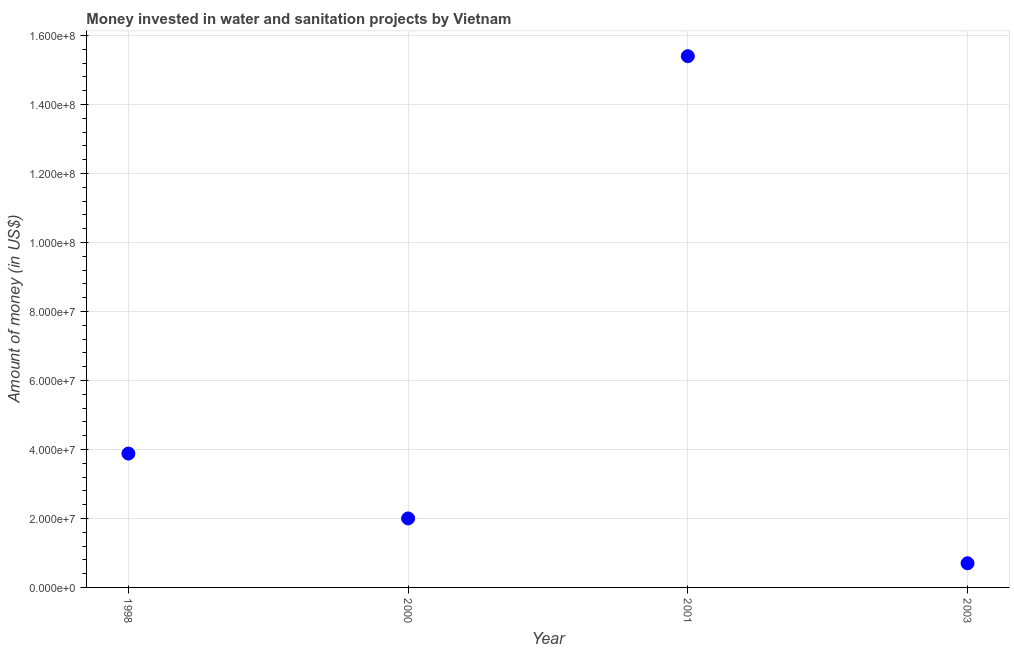What is the investment in 2001?
Provide a short and direct response. 1.54e+08. Across all years, what is the maximum investment?
Keep it short and to the point. 1.54e+08. Across all years, what is the minimum investment?
Offer a very short reply. 7.00e+06. In which year was the investment maximum?
Your response must be concise. 2001. What is the sum of the investment?
Make the answer very short. 2.20e+08. What is the difference between the investment in 1998 and 2000?
Give a very brief answer. 1.88e+07. What is the average investment per year?
Make the answer very short. 5.50e+07. What is the median investment?
Make the answer very short. 2.94e+07. In how many years, is the investment greater than 124000000 US$?
Ensure brevity in your answer.  1. What is the ratio of the investment in 1998 to that in 2001?
Give a very brief answer. 0.25. What is the difference between the highest and the second highest investment?
Your answer should be compact. 1.15e+08. What is the difference between the highest and the lowest investment?
Your answer should be compact. 1.47e+08. How many dotlines are there?
Provide a succinct answer. 1. How many years are there in the graph?
Offer a very short reply. 4. Does the graph contain grids?
Offer a very short reply. Yes. What is the title of the graph?
Your answer should be compact. Money invested in water and sanitation projects by Vietnam. What is the label or title of the X-axis?
Your response must be concise. Year. What is the label or title of the Y-axis?
Give a very brief answer. Amount of money (in US$). What is the Amount of money (in US$) in 1998?
Ensure brevity in your answer.  3.88e+07. What is the Amount of money (in US$) in 2001?
Your answer should be compact. 1.54e+08. What is the Amount of money (in US$) in 2003?
Keep it short and to the point. 7.00e+06. What is the difference between the Amount of money (in US$) in 1998 and 2000?
Your answer should be compact. 1.88e+07. What is the difference between the Amount of money (in US$) in 1998 and 2001?
Your answer should be very brief. -1.15e+08. What is the difference between the Amount of money (in US$) in 1998 and 2003?
Your response must be concise. 3.18e+07. What is the difference between the Amount of money (in US$) in 2000 and 2001?
Your response must be concise. -1.34e+08. What is the difference between the Amount of money (in US$) in 2000 and 2003?
Your answer should be compact. 1.30e+07. What is the difference between the Amount of money (in US$) in 2001 and 2003?
Ensure brevity in your answer.  1.47e+08. What is the ratio of the Amount of money (in US$) in 1998 to that in 2000?
Give a very brief answer. 1.94. What is the ratio of the Amount of money (in US$) in 1998 to that in 2001?
Make the answer very short. 0.25. What is the ratio of the Amount of money (in US$) in 1998 to that in 2003?
Your response must be concise. 5.54. What is the ratio of the Amount of money (in US$) in 2000 to that in 2001?
Offer a very short reply. 0.13. What is the ratio of the Amount of money (in US$) in 2000 to that in 2003?
Ensure brevity in your answer.  2.86. What is the ratio of the Amount of money (in US$) in 2001 to that in 2003?
Your answer should be very brief. 22. 